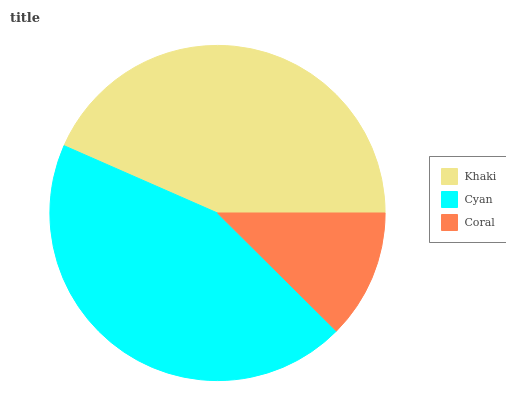Is Coral the minimum?
Answer yes or no. Yes. Is Cyan the maximum?
Answer yes or no. Yes. Is Cyan the minimum?
Answer yes or no. No. Is Coral the maximum?
Answer yes or no. No. Is Cyan greater than Coral?
Answer yes or no. Yes. Is Coral less than Cyan?
Answer yes or no. Yes. Is Coral greater than Cyan?
Answer yes or no. No. Is Cyan less than Coral?
Answer yes or no. No. Is Khaki the high median?
Answer yes or no. Yes. Is Khaki the low median?
Answer yes or no. Yes. Is Coral the high median?
Answer yes or no. No. Is Coral the low median?
Answer yes or no. No. 